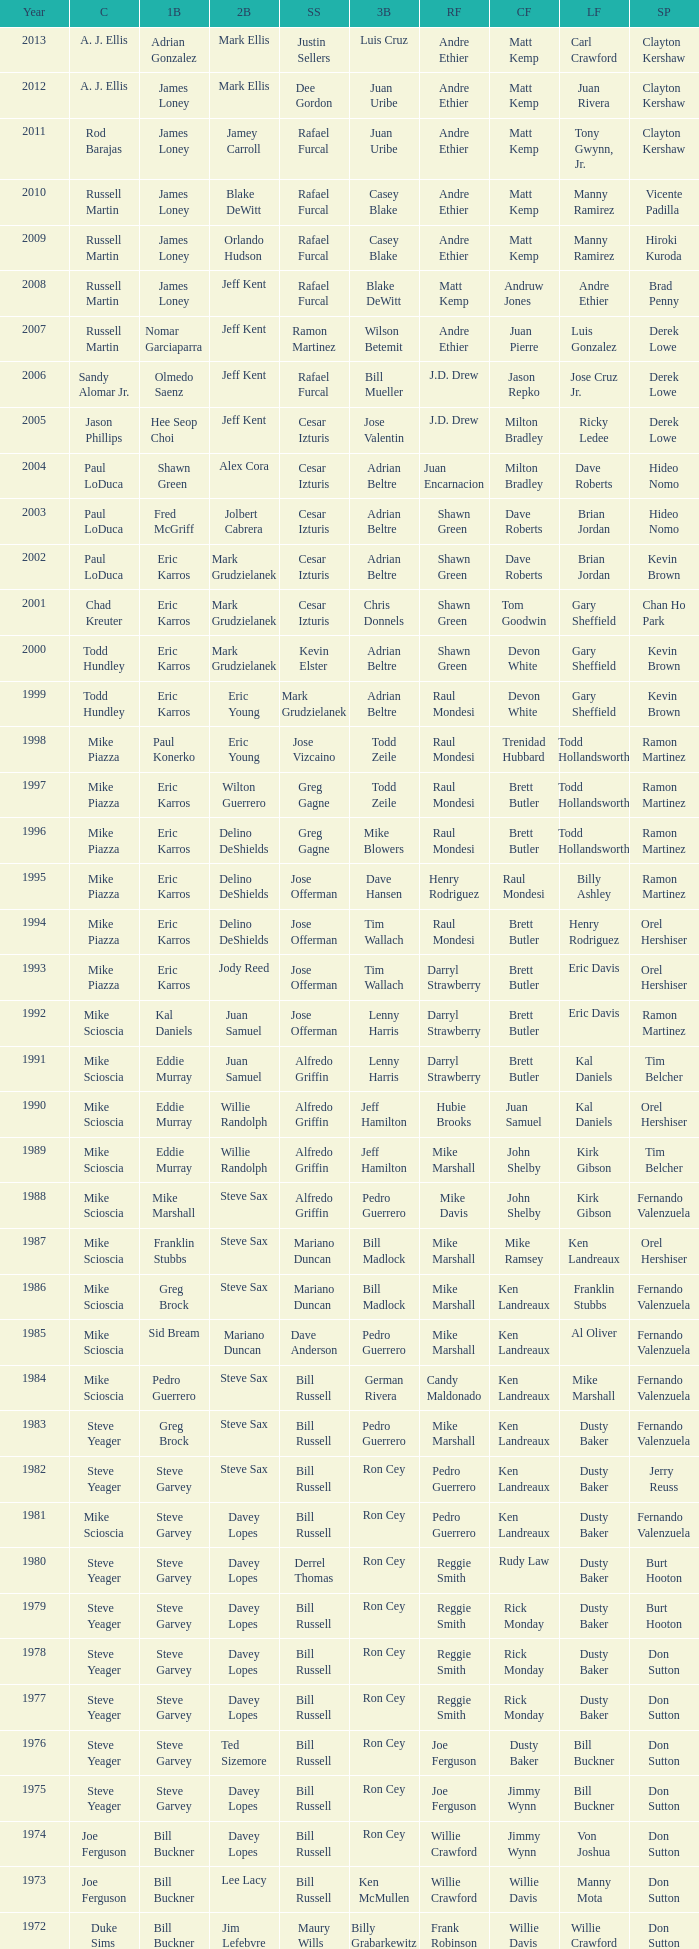Who played SS when paul konerko played 1st base? Jose Vizcaino. 